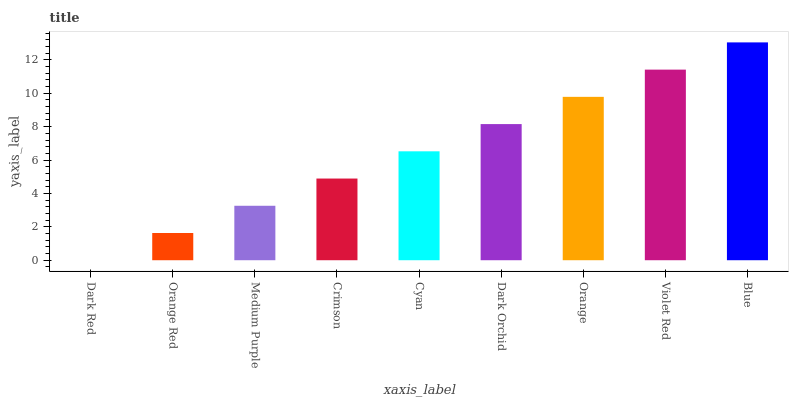Is Orange Red the minimum?
Answer yes or no. No. Is Orange Red the maximum?
Answer yes or no. No. Is Orange Red greater than Dark Red?
Answer yes or no. Yes. Is Dark Red less than Orange Red?
Answer yes or no. Yes. Is Dark Red greater than Orange Red?
Answer yes or no. No. Is Orange Red less than Dark Red?
Answer yes or no. No. Is Cyan the high median?
Answer yes or no. Yes. Is Cyan the low median?
Answer yes or no. Yes. Is Dark Red the high median?
Answer yes or no. No. Is Dark Red the low median?
Answer yes or no. No. 